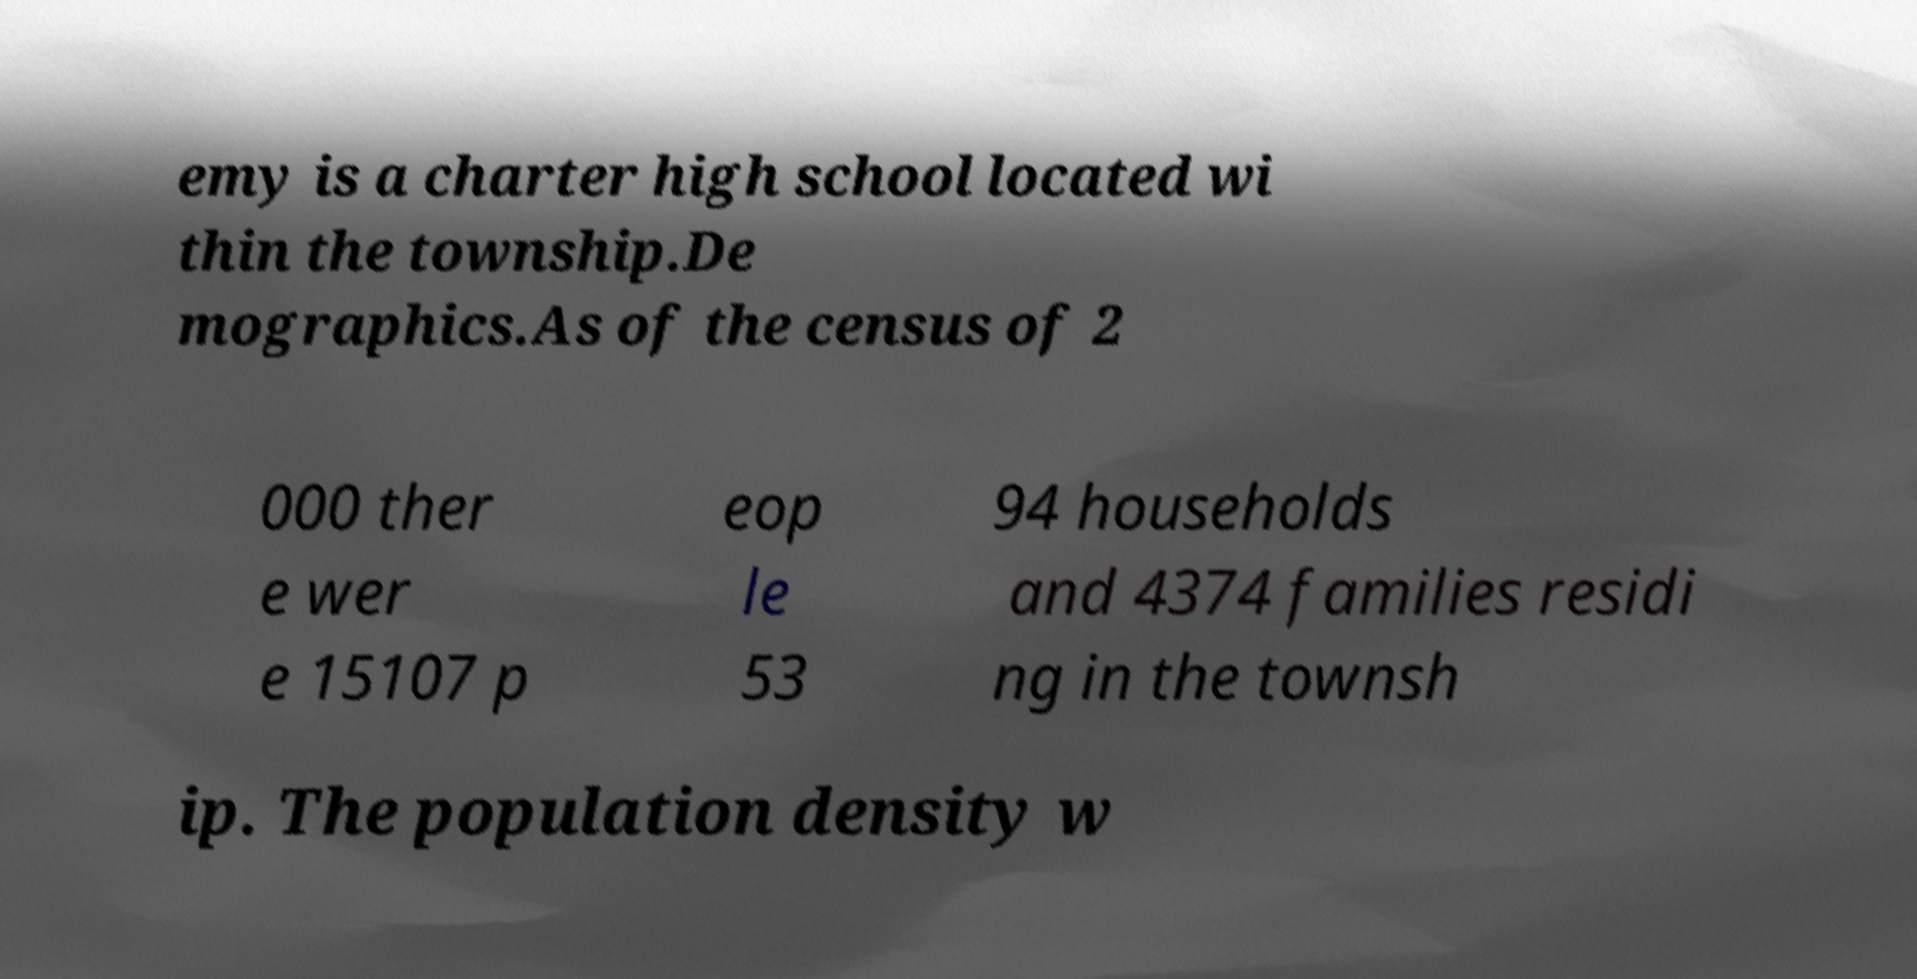Please identify and transcribe the text found in this image. emy is a charter high school located wi thin the township.De mographics.As of the census of 2 000 ther e wer e 15107 p eop le 53 94 households and 4374 families residi ng in the townsh ip. The population density w 